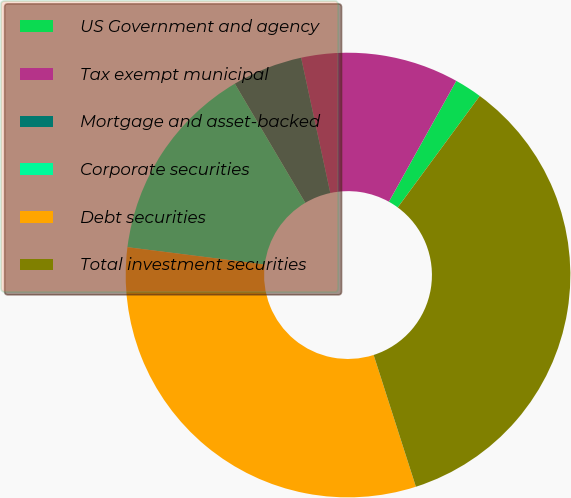Convert chart to OTSL. <chart><loc_0><loc_0><loc_500><loc_500><pie_chart><fcel>US Government and agency<fcel>Tax exempt municipal<fcel>Mortgage and asset-backed<fcel>Corporate securities<fcel>Debt securities<fcel>Total investment securities<nl><fcel>2.0%<fcel>11.48%<fcel>5.12%<fcel>14.5%<fcel>31.94%<fcel>34.97%<nl></chart> 